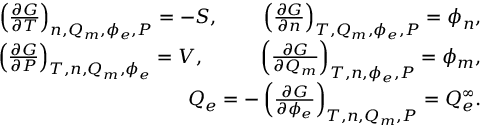Convert formula to latex. <formula><loc_0><loc_0><loc_500><loc_500>\begin{array} { r l r } & { \left ( \frac { \partial G } { \partial T } \right ) _ { n , Q _ { m } , \phi _ { e } , P } = - S , \, \left ( \frac { \partial G } { \partial n } \right ) _ { T , Q _ { m } , \phi _ { e } , P } = \phi _ { n } , } \\ & { \left ( \frac { \partial G } { \partial P } \right ) _ { T , n , Q _ { m } , \phi _ { e } } = V , \, \left ( \frac { \partial G } { \partial Q _ { m } } \right ) _ { T , n , \phi _ { e } , P } = \phi _ { m } , } \\ & { \, Q _ { e } = - \left ( \frac { \partial G } { \partial \phi _ { e } } \right ) _ { T , n , Q _ { m } , P } = Q _ { e } ^ { \infty } . } \end{array}</formula> 